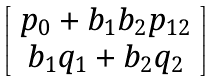Convert formula to latex. <formula><loc_0><loc_0><loc_500><loc_500>\left [ \begin{array} { c } { { p _ { 0 } + b _ { 1 } b _ { 2 } p _ { 1 2 } } } \\ { { b _ { 1 } q _ { 1 } + b _ { 2 } q _ { 2 } } } \end{array} \right ]</formula> 